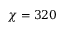<formula> <loc_0><loc_0><loc_500><loc_500>\chi = 3 2 0</formula> 